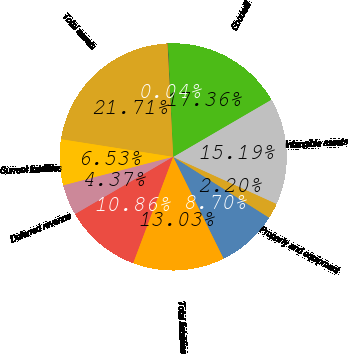Convert chart to OTSL. <chart><loc_0><loc_0><loc_500><loc_500><pie_chart><fcel>Current assets<fcel>Property and equipment<fcel>Intangible assets<fcel>Goodwill<fcel>Other long-term assets<fcel>Total assets<fcel>Current liabilities<fcel>Deferred revenue<fcel>Deferred taxes<fcel>Total liabilities<nl><fcel>8.7%<fcel>2.2%<fcel>15.19%<fcel>17.36%<fcel>0.04%<fcel>21.71%<fcel>6.53%<fcel>4.37%<fcel>10.86%<fcel>13.03%<nl></chart> 